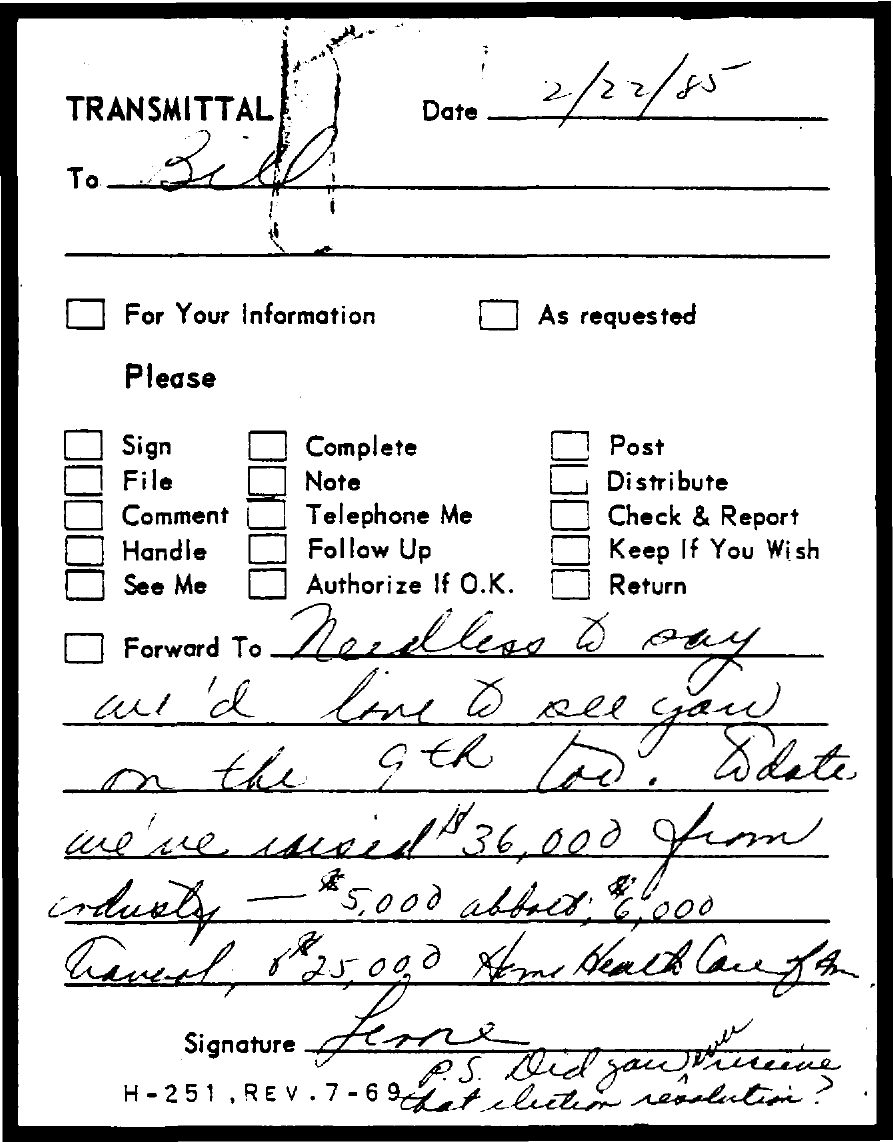What is the date mentioned in the transmittal?
Offer a very short reply. 2/22/85. To whom, the transmittal is addressed?
Your answer should be compact. Bill. 